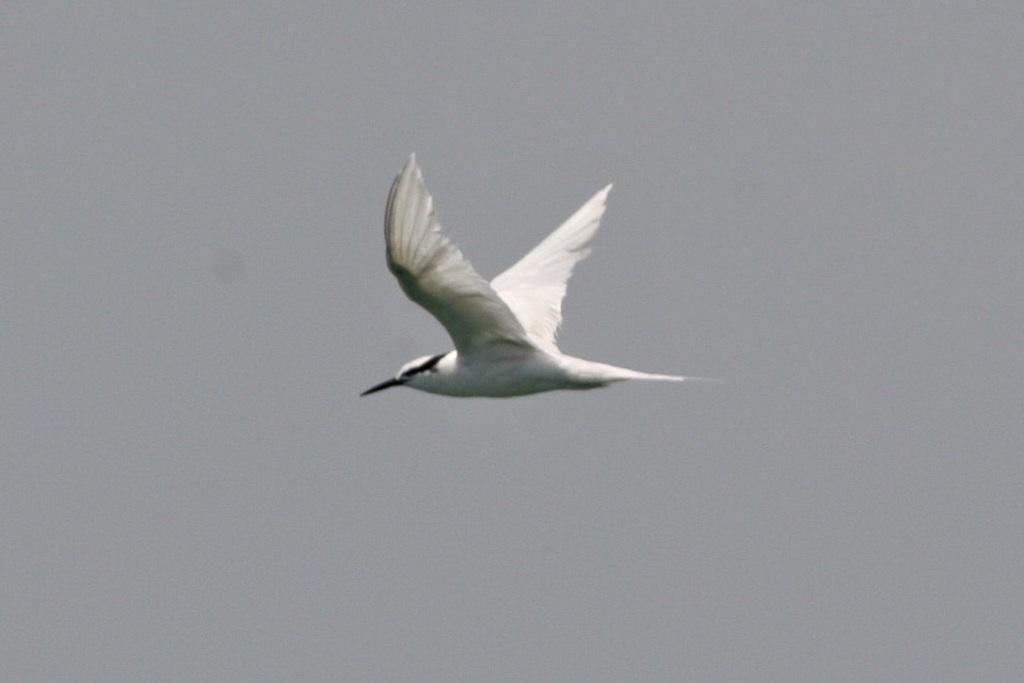What type of animal can be seen in the image? There is a bird in the image. What is the bird doing in the image? The bird is flying in the sky. What type of swing can be seen in the image? There is no swing present in the image; it only features a bird flying in the sky. What type of brush is being used by the bird in the image? There is no brush present in the image, and the bird is not using any tool or object. 